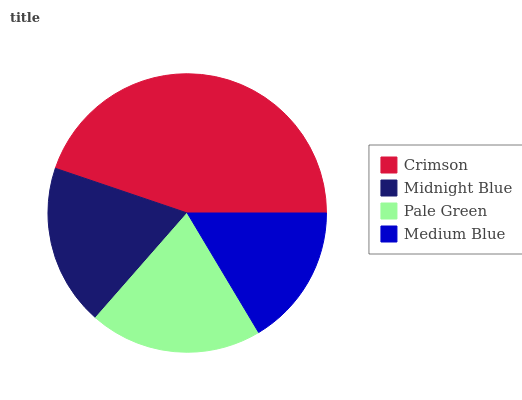Is Medium Blue the minimum?
Answer yes or no. Yes. Is Crimson the maximum?
Answer yes or no. Yes. Is Midnight Blue the minimum?
Answer yes or no. No. Is Midnight Blue the maximum?
Answer yes or no. No. Is Crimson greater than Midnight Blue?
Answer yes or no. Yes. Is Midnight Blue less than Crimson?
Answer yes or no. Yes. Is Midnight Blue greater than Crimson?
Answer yes or no. No. Is Crimson less than Midnight Blue?
Answer yes or no. No. Is Pale Green the high median?
Answer yes or no. Yes. Is Midnight Blue the low median?
Answer yes or no. Yes. Is Midnight Blue the high median?
Answer yes or no. No. Is Crimson the low median?
Answer yes or no. No. 